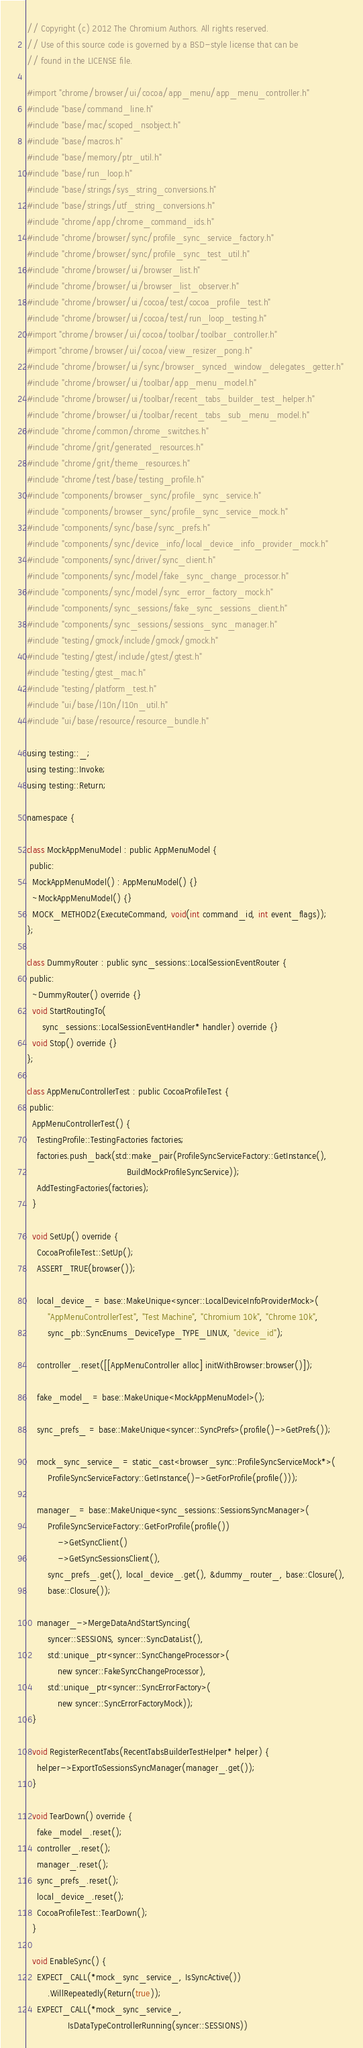<code> <loc_0><loc_0><loc_500><loc_500><_ObjectiveC_>// Copyright (c) 2012 The Chromium Authors. All rights reserved.
// Use of this source code is governed by a BSD-style license that can be
// found in the LICENSE file.

#import "chrome/browser/ui/cocoa/app_menu/app_menu_controller.h"
#include "base/command_line.h"
#include "base/mac/scoped_nsobject.h"
#include "base/macros.h"
#include "base/memory/ptr_util.h"
#include "base/run_loop.h"
#include "base/strings/sys_string_conversions.h"
#include "base/strings/utf_string_conversions.h"
#include "chrome/app/chrome_command_ids.h"
#include "chrome/browser/sync/profile_sync_service_factory.h"
#include "chrome/browser/sync/profile_sync_test_util.h"
#include "chrome/browser/ui/browser_list.h"
#include "chrome/browser/ui/browser_list_observer.h"
#include "chrome/browser/ui/cocoa/test/cocoa_profile_test.h"
#include "chrome/browser/ui/cocoa/test/run_loop_testing.h"
#import "chrome/browser/ui/cocoa/toolbar/toolbar_controller.h"
#import "chrome/browser/ui/cocoa/view_resizer_pong.h"
#include "chrome/browser/ui/sync/browser_synced_window_delegates_getter.h"
#include "chrome/browser/ui/toolbar/app_menu_model.h"
#include "chrome/browser/ui/toolbar/recent_tabs_builder_test_helper.h"
#include "chrome/browser/ui/toolbar/recent_tabs_sub_menu_model.h"
#include "chrome/common/chrome_switches.h"
#include "chrome/grit/generated_resources.h"
#include "chrome/grit/theme_resources.h"
#include "chrome/test/base/testing_profile.h"
#include "components/browser_sync/profile_sync_service.h"
#include "components/browser_sync/profile_sync_service_mock.h"
#include "components/sync/base/sync_prefs.h"
#include "components/sync/device_info/local_device_info_provider_mock.h"
#include "components/sync/driver/sync_client.h"
#include "components/sync/model/fake_sync_change_processor.h"
#include "components/sync/model/sync_error_factory_mock.h"
#include "components/sync_sessions/fake_sync_sessions_client.h"
#include "components/sync_sessions/sessions_sync_manager.h"
#include "testing/gmock/include/gmock/gmock.h"
#include "testing/gtest/include/gtest/gtest.h"
#include "testing/gtest_mac.h"
#include "testing/platform_test.h"
#include "ui/base/l10n/l10n_util.h"
#include "ui/base/resource/resource_bundle.h"

using testing::_;
using testing::Invoke;
using testing::Return;

namespace {

class MockAppMenuModel : public AppMenuModel {
 public:
  MockAppMenuModel() : AppMenuModel() {}
  ~MockAppMenuModel() {}
  MOCK_METHOD2(ExecuteCommand, void(int command_id, int event_flags));
};

class DummyRouter : public sync_sessions::LocalSessionEventRouter {
 public:
  ~DummyRouter() override {}
  void StartRoutingTo(
      sync_sessions::LocalSessionEventHandler* handler) override {}
  void Stop() override {}
};

class AppMenuControllerTest : public CocoaProfileTest {
 public:
  AppMenuControllerTest() {
    TestingProfile::TestingFactories factories;
    factories.push_back(std::make_pair(ProfileSyncServiceFactory::GetInstance(),
                                       BuildMockProfileSyncService));
    AddTestingFactories(factories);
  }

  void SetUp() override {
    CocoaProfileTest::SetUp();
    ASSERT_TRUE(browser());

    local_device_ = base::MakeUnique<syncer::LocalDeviceInfoProviderMock>(
        "AppMenuControllerTest", "Test Machine", "Chromium 10k", "Chrome 10k",
        sync_pb::SyncEnums_DeviceType_TYPE_LINUX, "device_id");

    controller_.reset([[AppMenuController alloc] initWithBrowser:browser()]);

    fake_model_ = base::MakeUnique<MockAppMenuModel>();

    sync_prefs_ = base::MakeUnique<syncer::SyncPrefs>(profile()->GetPrefs());

    mock_sync_service_ = static_cast<browser_sync::ProfileSyncServiceMock*>(
        ProfileSyncServiceFactory::GetInstance()->GetForProfile(profile()));

    manager_ = base::MakeUnique<sync_sessions::SessionsSyncManager>(
        ProfileSyncServiceFactory::GetForProfile(profile())
            ->GetSyncClient()
            ->GetSyncSessionsClient(),
        sync_prefs_.get(), local_device_.get(), &dummy_router_, base::Closure(),
        base::Closure());

    manager_->MergeDataAndStartSyncing(
        syncer::SESSIONS, syncer::SyncDataList(),
        std::unique_ptr<syncer::SyncChangeProcessor>(
            new syncer::FakeSyncChangeProcessor),
        std::unique_ptr<syncer::SyncErrorFactory>(
            new syncer::SyncErrorFactoryMock));
  }

  void RegisterRecentTabs(RecentTabsBuilderTestHelper* helper) {
    helper->ExportToSessionsSyncManager(manager_.get());
  }

  void TearDown() override {
    fake_model_.reset();
    controller_.reset();
    manager_.reset();
    sync_prefs_.reset();
    local_device_.reset();
    CocoaProfileTest::TearDown();
  }

  void EnableSync() {
    EXPECT_CALL(*mock_sync_service_, IsSyncActive())
        .WillRepeatedly(Return(true));
    EXPECT_CALL(*mock_sync_service_,
                IsDataTypeControllerRunning(syncer::SESSIONS))</code> 